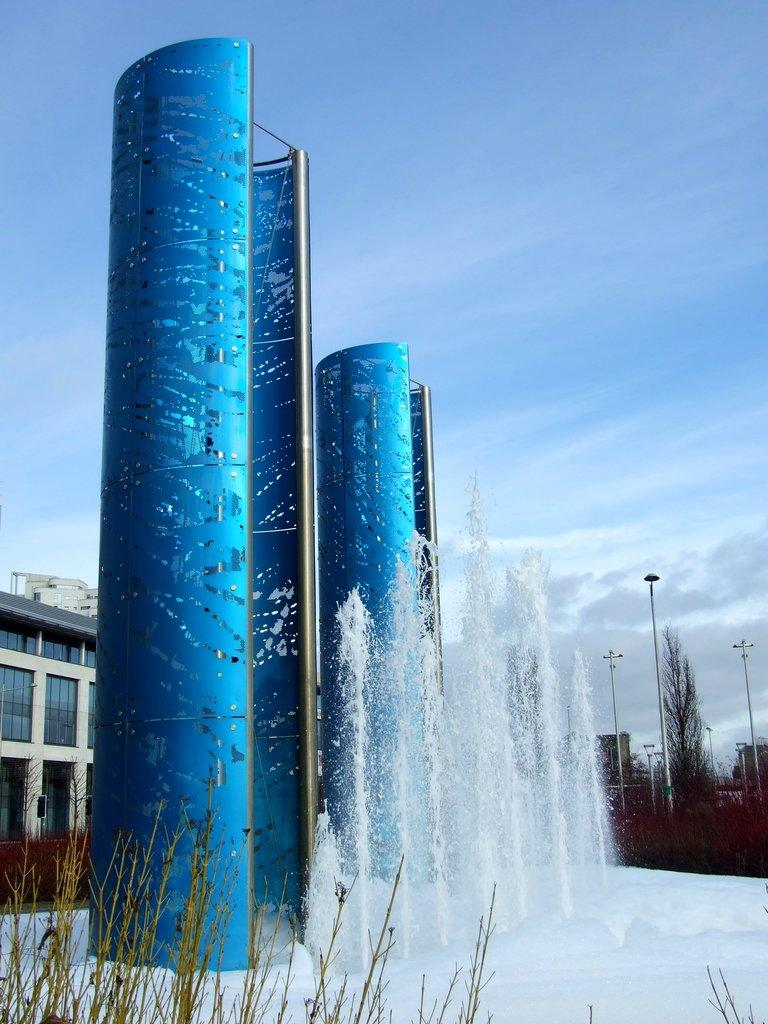What type of structure can be seen in the image? There is a building in the image. What is another feature visible in the image? There is a water fountain in the image. What objects are present in the image that might be used for support or guidance? There are poles in the image. What type of natural elements can be seen in the image? There are trees and plants in the image. What type of brush is being used to paint the locket in the image? There is no brush or locket present in the image. How many people are talking to each other in the image? There is no conversation or people talking to each other in the image. 